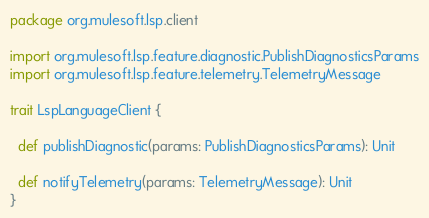<code> <loc_0><loc_0><loc_500><loc_500><_Scala_>package org.mulesoft.lsp.client

import org.mulesoft.lsp.feature.diagnostic.PublishDiagnosticsParams
import org.mulesoft.lsp.feature.telemetry.TelemetryMessage

trait LspLanguageClient {

  def publishDiagnostic(params: PublishDiagnosticsParams): Unit

  def notifyTelemetry(params: TelemetryMessage): Unit
}
</code> 